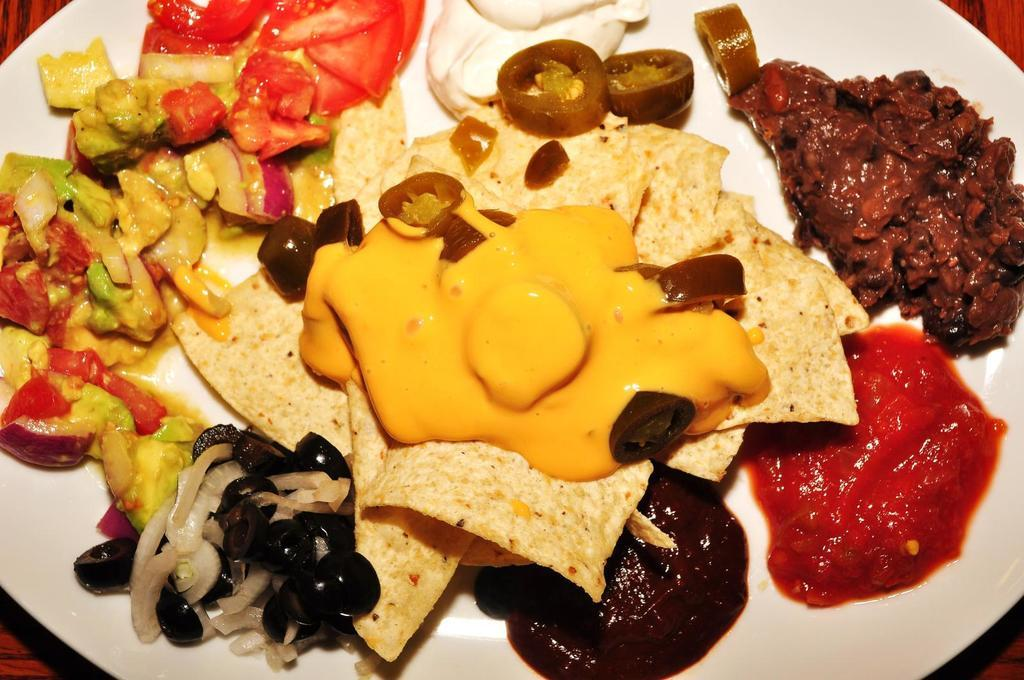What type of dish is present on the plate in the image? There is a white color plate in the image. What food items are on the plate? There are vegetable salads and curries on the plate. What is the color of the cream on the plate? The cream on the plate is yellow-colored. How many books can be seen on the plate in the image? There are no books present on the plate in the image; it contains vegetable salads, curries, and yellow-colored cream. 